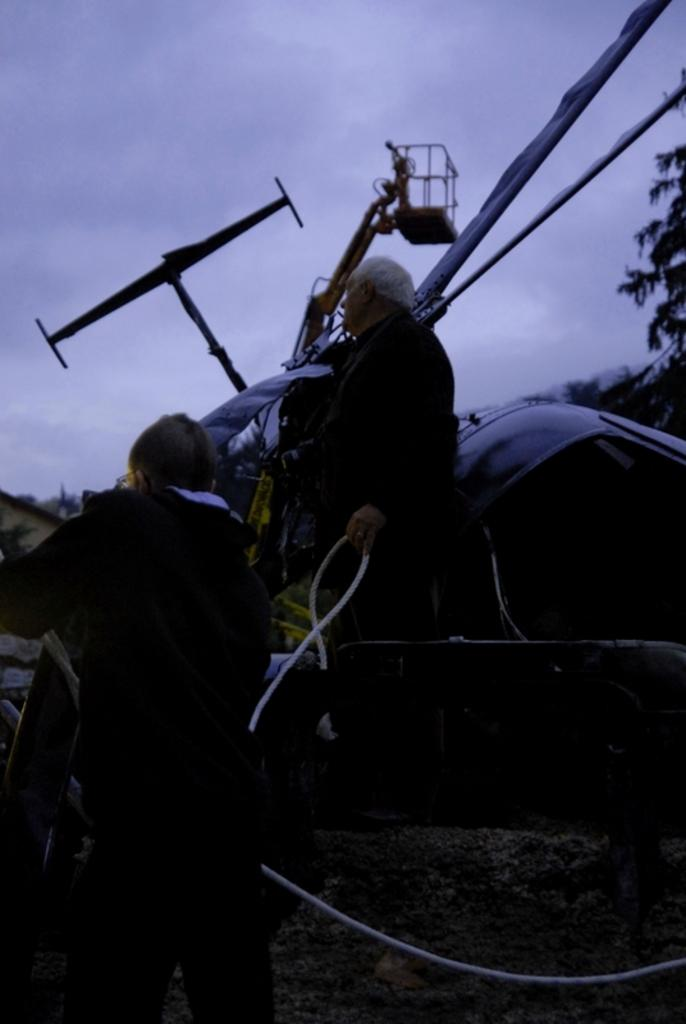What is located on the left side of the image? There is a man standing on the left side of the image. What is the man wearing in the image? The man is wearing a black sweater. What can be seen at the top of the image? The sky is visible at the top of the image. Is there a kite flying in the yard in the image? There is no yard or kite present in the image. 